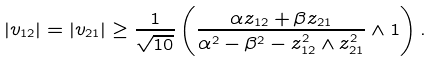Convert formula to latex. <formula><loc_0><loc_0><loc_500><loc_500>| v _ { 1 2 } | = | v _ { 2 1 } | \geq \frac { 1 } { \sqrt { 1 0 } } \left ( \frac { \alpha z _ { 1 2 } + \beta z _ { 2 1 } } { \alpha ^ { 2 } - \beta ^ { 2 } - z _ { 1 2 } ^ { 2 } \wedge z _ { 2 1 } ^ { 2 } } \wedge 1 \right ) . \\</formula> 